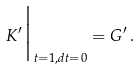<formula> <loc_0><loc_0><loc_500><loc_500>K ^ { \prime } \Big | _ { t = 1 , d t = 0 } = G ^ { \prime } \, .</formula> 